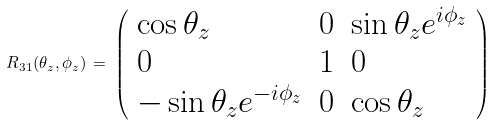Convert formula to latex. <formula><loc_0><loc_0><loc_500><loc_500>R _ { 3 1 } ( \theta _ { z } , \phi _ { z } ) \, = \, \left ( \begin{array} { l l l } { { \cos \theta _ { z } } } & { 0 } & { { \sin \theta _ { z } e ^ { i \phi _ { z } } } } \\ { 0 } & { 1 } & { 0 } \\ { { - \sin \theta _ { z } e ^ { - i \phi _ { z } } } } & { 0 } & { { \cos \theta _ { z } } } \end{array} \right )</formula> 